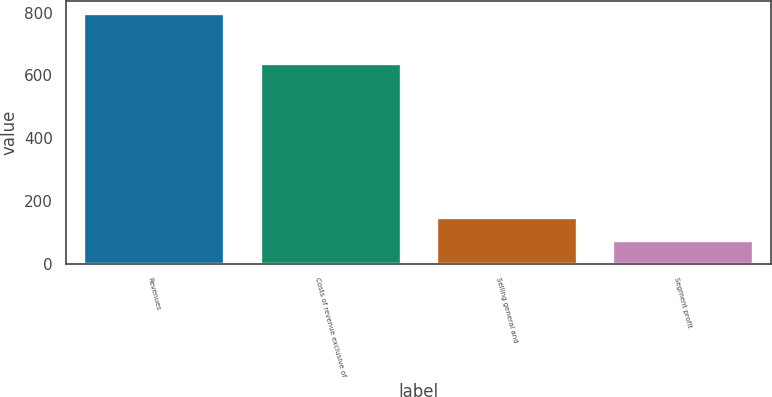<chart> <loc_0><loc_0><loc_500><loc_500><bar_chart><fcel>Revenues<fcel>Costs of revenue exclusive of<fcel>Selling general and<fcel>Segment profit<nl><fcel>797<fcel>639<fcel>148.1<fcel>76<nl></chart> 